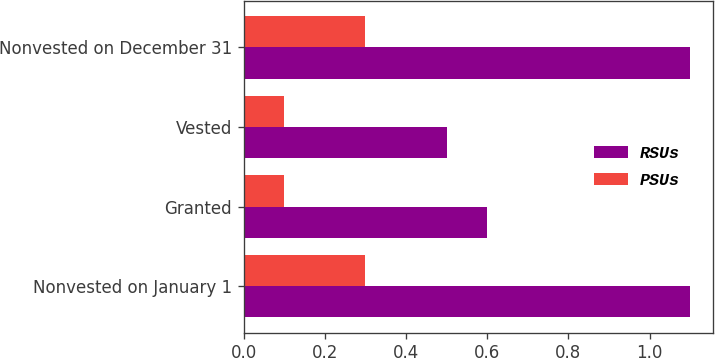<chart> <loc_0><loc_0><loc_500><loc_500><stacked_bar_chart><ecel><fcel>Nonvested on January 1<fcel>Granted<fcel>Vested<fcel>Nonvested on December 31<nl><fcel>RSUs<fcel>1.1<fcel>0.6<fcel>0.5<fcel>1.1<nl><fcel>PSUs<fcel>0.3<fcel>0.1<fcel>0.1<fcel>0.3<nl></chart> 